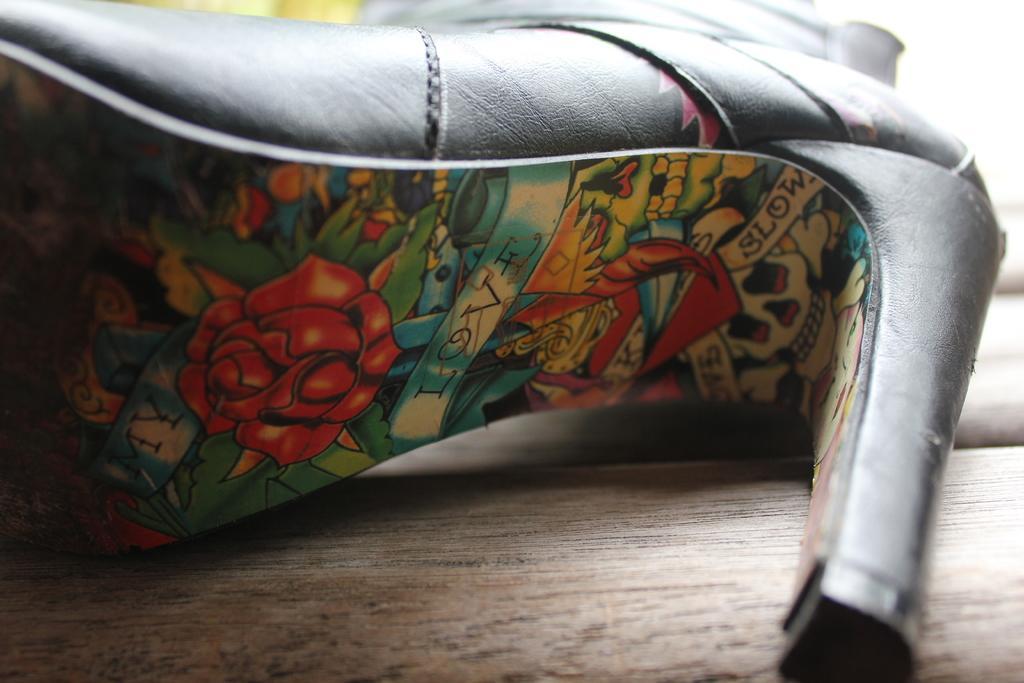Can you describe this image briefly? This is a zoomed in picture. In the foreground we can see a wooden object. In the center there is a heel lying on a wooden object and we can see the text and the depictions of flower, leaves and some other objects on the sole of the heel. In the background we can see some other objects. 